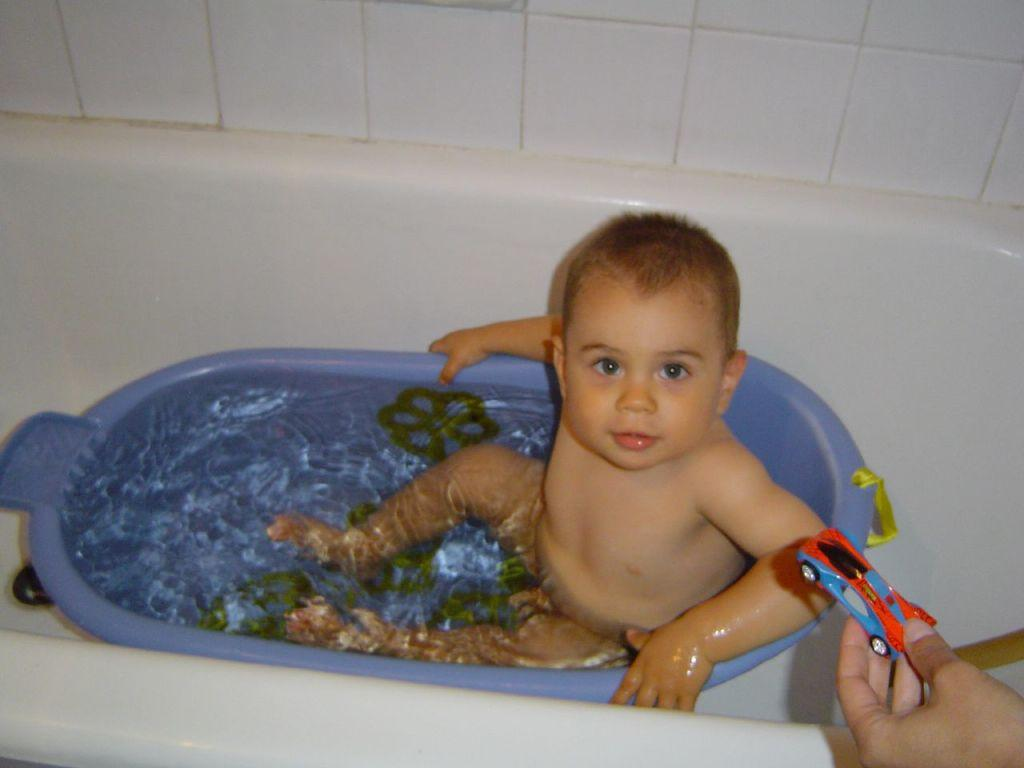What is the main subject of the image? The main subject of the image is a little boy in the bathtub. How is the little boy described? The boy is described as cute. What type of toy can be seen in the image? There is a car toy in the image. Who is holding the car toy? The car toy is being held by a human. What color is the bathtub? The bathtub is blue in color. What type of rake is being used to develop the heat in the image? There is no rake or development of heat present in the image; it features a little boy in a bathtub with a car toy. 